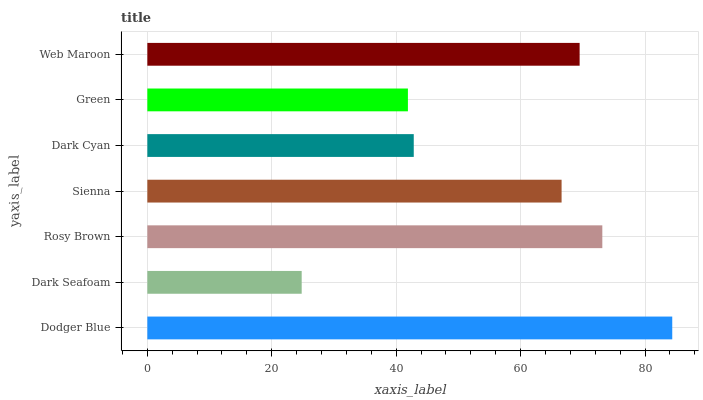Is Dark Seafoam the minimum?
Answer yes or no. Yes. Is Dodger Blue the maximum?
Answer yes or no. Yes. Is Rosy Brown the minimum?
Answer yes or no. No. Is Rosy Brown the maximum?
Answer yes or no. No. Is Rosy Brown greater than Dark Seafoam?
Answer yes or no. Yes. Is Dark Seafoam less than Rosy Brown?
Answer yes or no. Yes. Is Dark Seafoam greater than Rosy Brown?
Answer yes or no. No. Is Rosy Brown less than Dark Seafoam?
Answer yes or no. No. Is Sienna the high median?
Answer yes or no. Yes. Is Sienna the low median?
Answer yes or no. Yes. Is Green the high median?
Answer yes or no. No. Is Dark Cyan the low median?
Answer yes or no. No. 